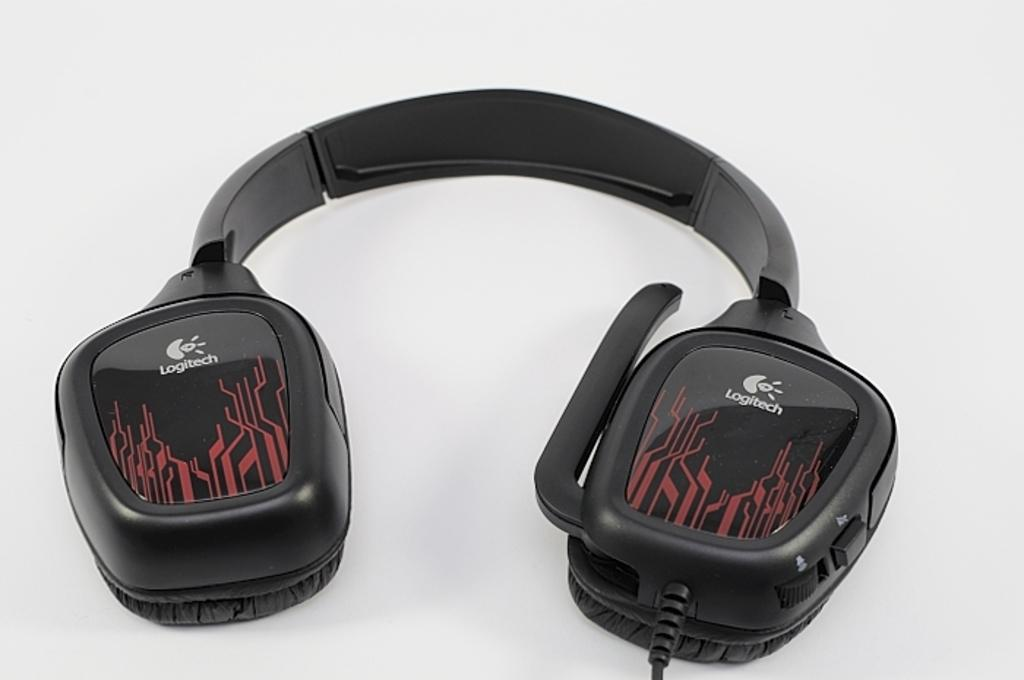<image>
Provide a brief description of the given image. Logitech has headphones that are black and red. 